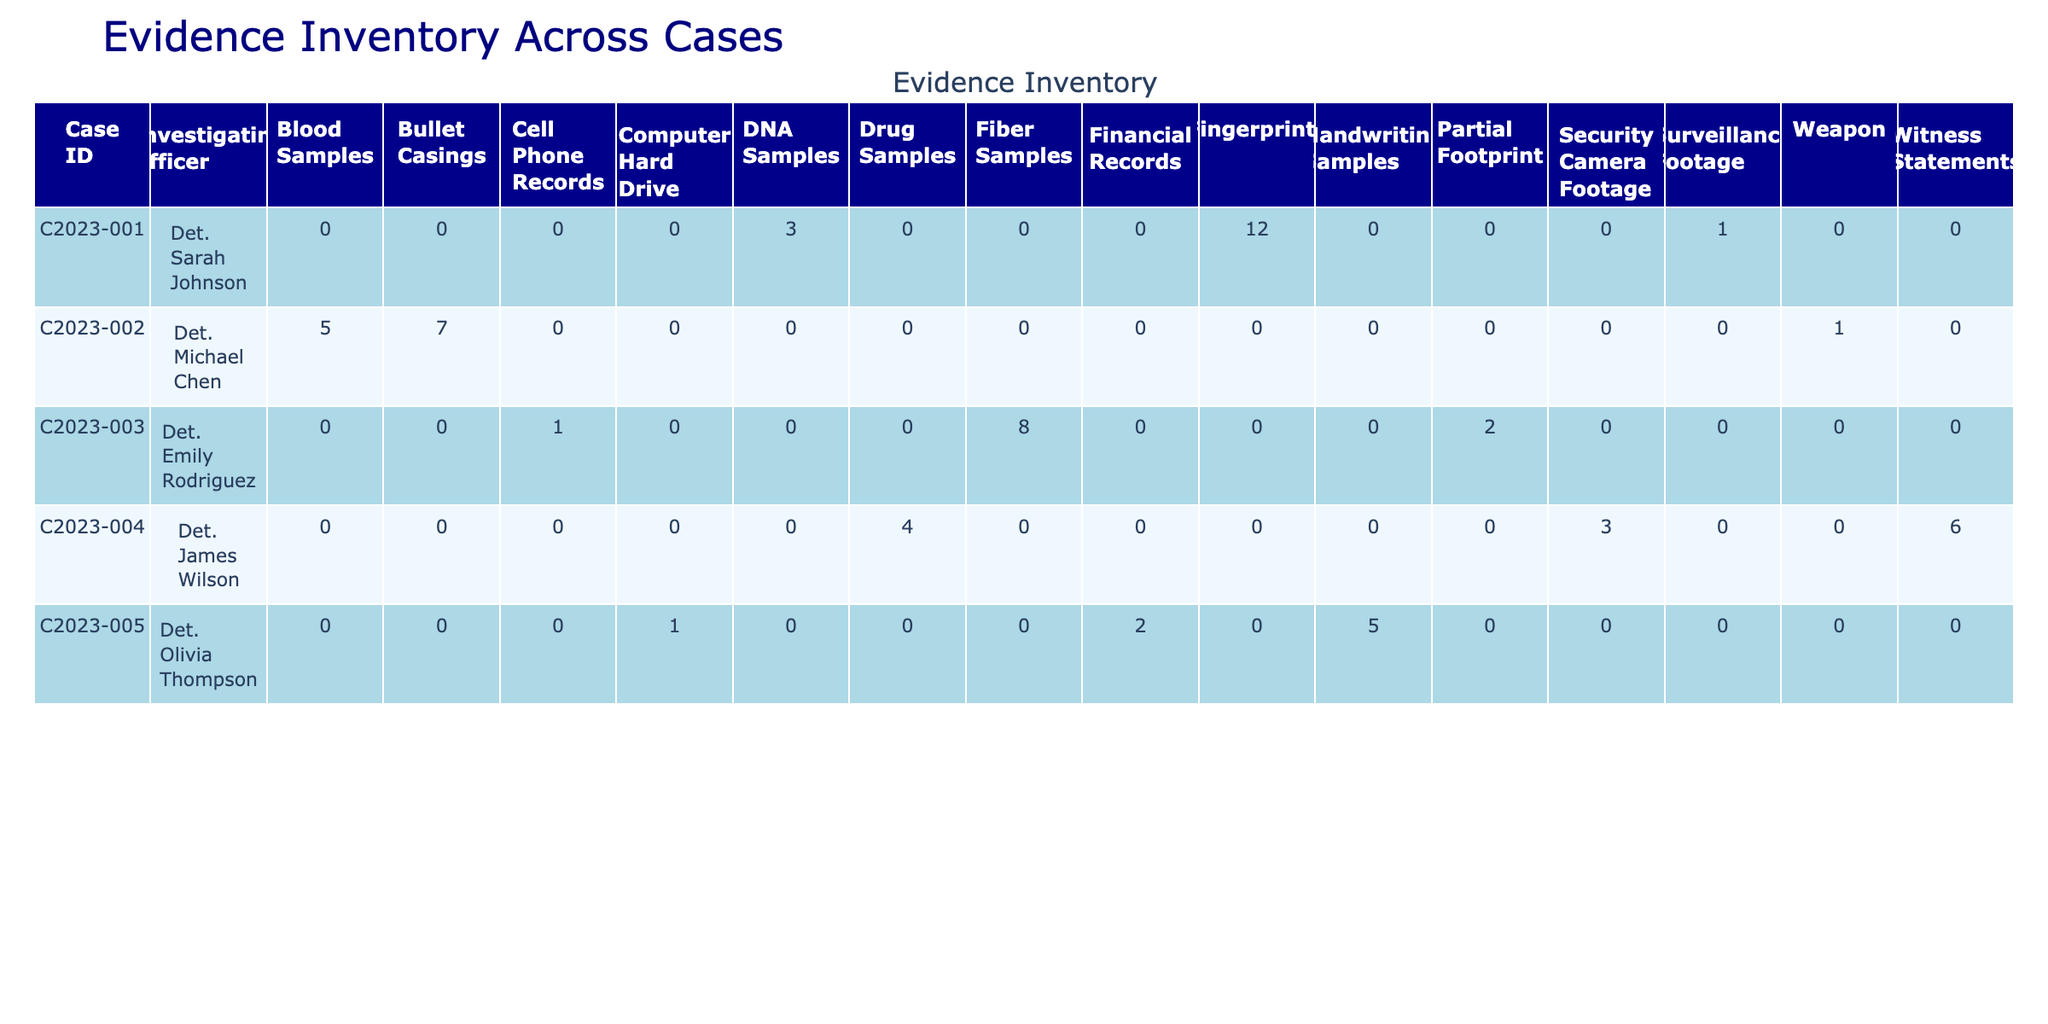What is the total quantity of evidence collected for Case ID C2023-002? In the table, we look for the row with Case ID C2023-002. The quantities for this case are 7 (Bullet Casings), 1 (Weapon), and 5 (Blood Samples). We add these quantities together: 7 + 1 + 5 = 13.
Answer: 13 Which investigating officer collected the DNA Samples? We check the Evidence Type column for "DNA Samples." The row corresponding to this evidence type shows it was collected under Case ID C2023-001 by Det. Sarah Johnson.
Answer: Det. Sarah Johnson How many different types of evidence were collected for Case ID C2023-004? For Case ID C2023-004, we look at the rows and see three different evidence types: Security Camera Footage, Witness Statements, and Drug Samples. Therefore, there are 3 types of evidence collected.
Answer: 3 Did Det. Olivia Thompson collect any evidence in the Evidence Locker B? We search for "Det. Olivia Thompson" in the table and find that she collected Handwriting Samples in Evidence Locker B. So, the answer is yes, she did collect evidence there.
Answer: Yes What is the total quantity of fingerprints and blood samples collected across all cases? First, we identify the quantities for fingerprints which is 12 from Case ID C2023-001, and blood samples which is 5 from Case ID C2023-002. Then we sum them up: 12 (fingerprints) + 5 (blood samples) = 17.
Answer: 17 Which storage location has the highest total quantity of evidence collected? To find this, we analyze the quantities per storage location. Evidence Locker A had 12 (fingerprints) + 2 (partial footprints) = 14; Evidence Locker B had 7 (bullet casings) + 5 (handwriting samples) = 12; Evidence Locker C had 4 (drug samples); Armory had 1; Forensics Lab had 3 + 5 + 8 = 16; File Room had 2 + 6 = 8; Digital Storage Unit had 1 + 3 + 1 = 5. The highest total is from Forensics Lab with 16.
Answer: Forensics Lab How many evidence types were collected by Det. Michael Chen? We look for Det. Michael Chen's rows. He collected Bullet Casings, Weapon, and Blood Samples which are a total of 3 different evidence types.
Answer: 3 Was there any evidence collected on the date of January 16, 2023? We search for the date January 16, 2023, in the Date Collected column, and find that DNA Samples were collected on that date by Det. Sarah Johnson. So the answer is yes.
Answer: Yes What is the average quantity of evidence collected per case? We first sum the total quantity of evidence across all cases: 12 + 3 + 1 + 7 + 1 + 5 + 2 + 8 + 1 + 3 + 6 + 4 + 2 + 1 + 5 = 56. There are 5 cases in total. To find the average, we divide the total quantity (56) by the number of cases (5): 56 / 5 = 11.2.
Answer: 11.2 